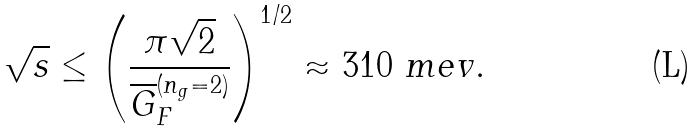Convert formula to latex. <formula><loc_0><loc_0><loc_500><loc_500>\sqrt { s } \leq \left ( \frac { \pi \sqrt { 2 } } { \overline { G } ^ { ( n _ { g } = 2 ) } _ { F } } \right ) ^ { 1 / 2 } \approx 3 1 0 \ m e v .</formula> 